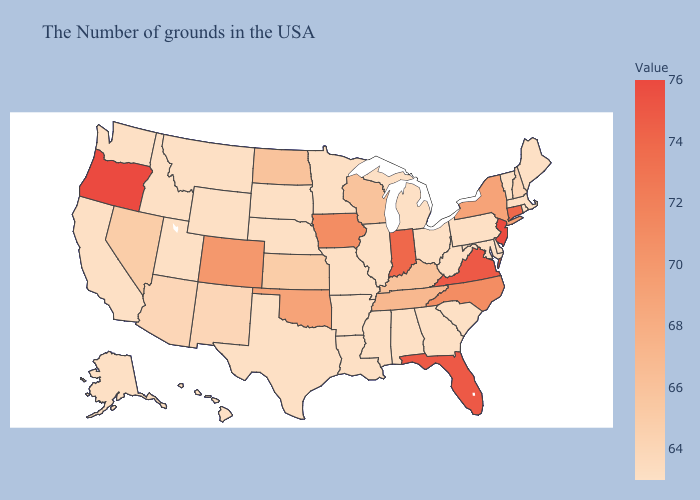Among the states that border Alabama , does Tennessee have the lowest value?
Short answer required. No. Which states have the lowest value in the MidWest?
Be succinct. Ohio, Michigan, Illinois, Missouri, Minnesota, Nebraska, South Dakota. Among the states that border Illinois , which have the lowest value?
Concise answer only. Missouri. 